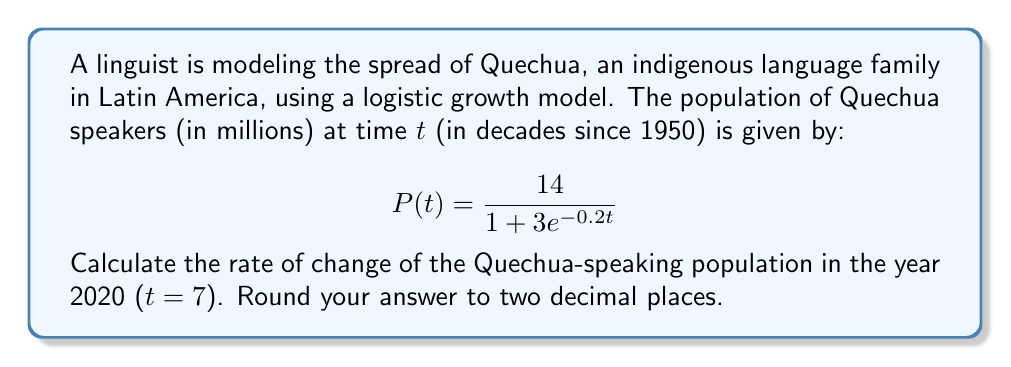Provide a solution to this math problem. To find the rate of change of the Quechua-speaking population in 2020, we need to follow these steps:

1) The logistic growth model is given by:
   $$P(t) = \frac{14}{1 + 3e^{-0.2t}}$$

2) To find the rate of change, we need to differentiate P(t) with respect to t:
   $$\frac{dP}{dt} = \frac{14 \cdot 3 \cdot 0.2 \cdot e^{-0.2t}}{(1 + 3e^{-0.2t})^2}$$

3) Simplify:
   $$\frac{dP}{dt} = \frac{8.4 \cdot e^{-0.2t}}{(1 + 3e^{-0.2t})^2}$$

4) Now, we need to evaluate this at t = 7 (2020):
   $$\frac{dP}{dt}\bigg|_{t=7} = \frac{8.4 \cdot e^{-0.2(7)}}{(1 + 3e^{-0.2(7)})^2}$$

5) Calculate $e^{-0.2(7)} = e^{-1.4} \approx 0.2466$

6) Substitute this value:
   $$\frac{dP}{dt}\bigg|_{t=7} = \frac{8.4 \cdot 0.2466}{(1 + 3 \cdot 0.2466)^2} \approx \frac{2.0714}{2.5439^2}$$

7) Calculate the final result:
   $$\frac{dP}{dt}\bigg|_{t=7} \approx 0.3199$$

8) Rounding to two decimal places:
   $$\frac{dP}{dt}\bigg|_{t=7} \approx 0.32$$
Answer: 0.32 million per decade 